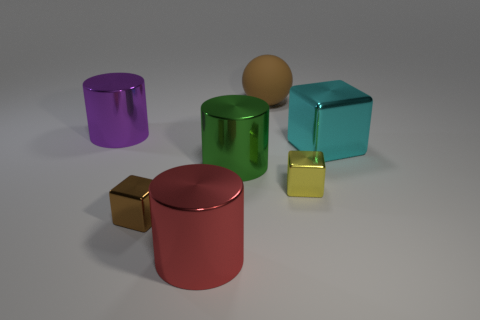How many cyan objects are metal cylinders or metallic things?
Give a very brief answer. 1. How many other things are the same shape as the large cyan metallic object?
Make the answer very short. 2. There is a small cube left of the green thing; is its color the same as the big rubber object that is behind the cyan shiny block?
Make the answer very short. Yes. What number of large objects are either blue rubber cylinders or brown metal cubes?
Your answer should be very brief. 0. There is a brown metal object that is the same shape as the cyan thing; what is its size?
Your answer should be compact. Small. What is the material of the brown thing behind the metal thing that is to the right of the yellow metallic thing?
Offer a very short reply. Rubber. How many metal things are small brown cubes or large green things?
Keep it short and to the point. 2. The other big metallic object that is the same shape as the brown metal object is what color?
Keep it short and to the point. Cyan. What number of tiny metallic blocks have the same color as the sphere?
Make the answer very short. 1. Are there any tiny metallic objects on the left side of the tiny shiny thing that is to the right of the red cylinder?
Your response must be concise. Yes. 